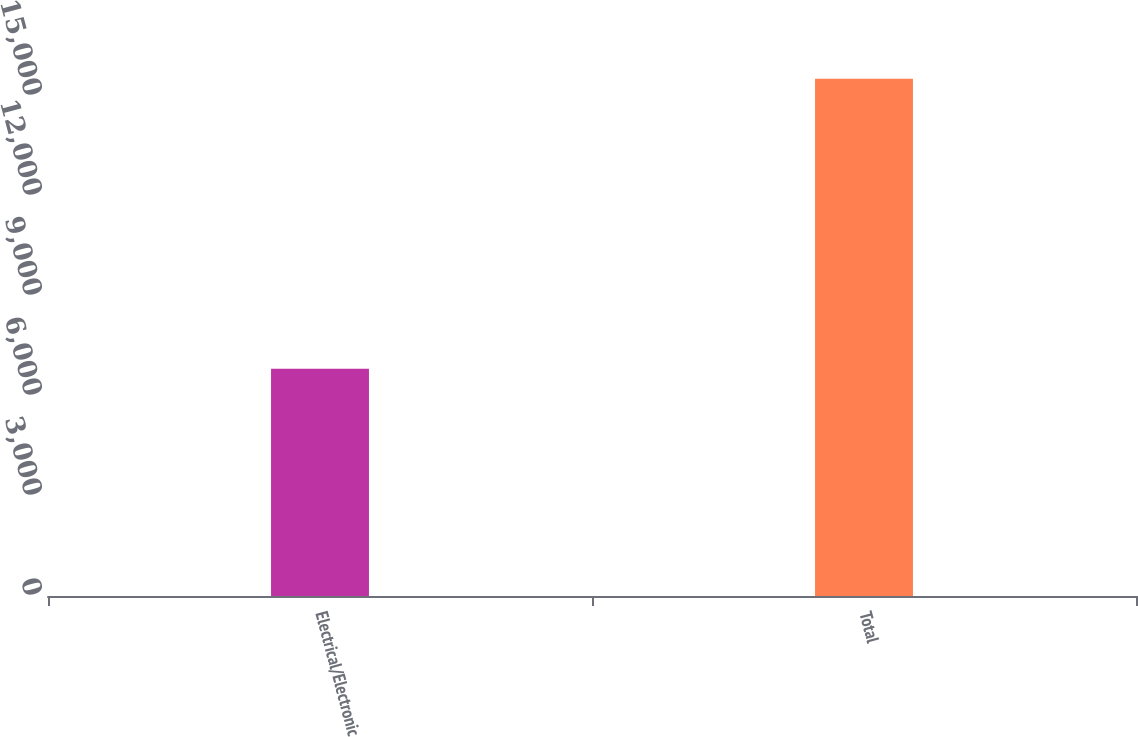Convert chart to OTSL. <chart><loc_0><loc_0><loc_500><loc_500><bar_chart><fcel>Electrical/Electronic<fcel>Total<nl><fcel>6815<fcel>15519<nl></chart> 